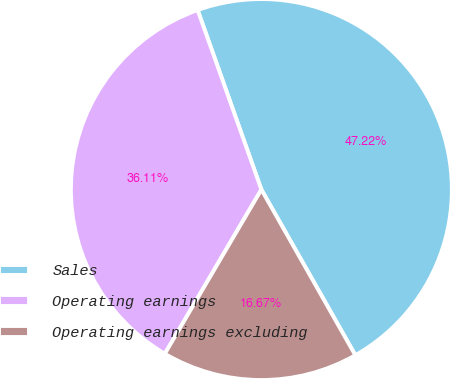Convert chart to OTSL. <chart><loc_0><loc_0><loc_500><loc_500><pie_chart><fcel>Sales<fcel>Operating earnings<fcel>Operating earnings excluding<nl><fcel>47.22%<fcel>36.11%<fcel>16.67%<nl></chart> 